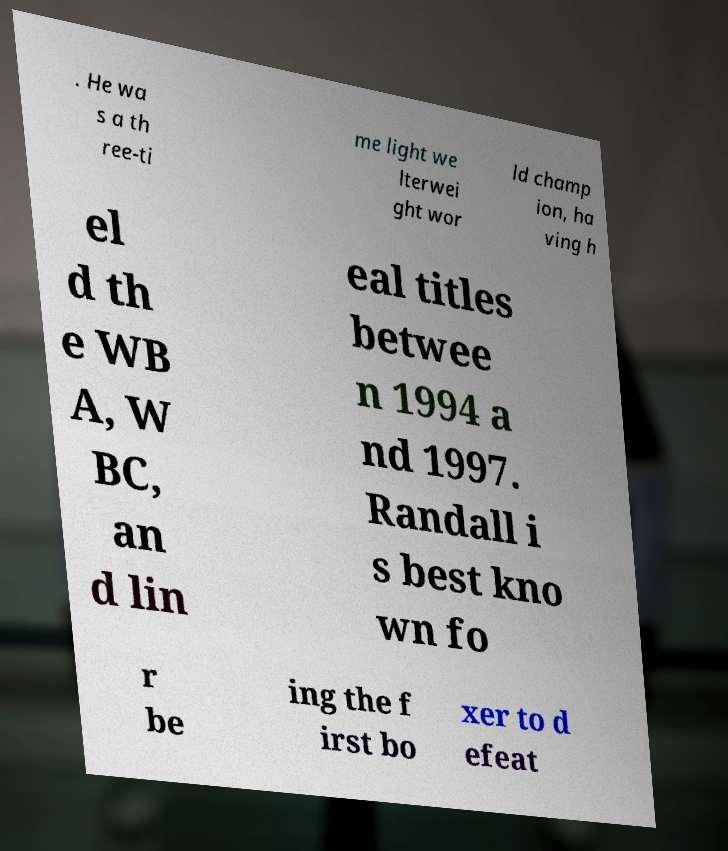What messages or text are displayed in this image? I need them in a readable, typed format. . He wa s a th ree-ti me light we lterwei ght wor ld champ ion, ha ving h el d th e WB A, W BC, an d lin eal titles betwee n 1994 a nd 1997. Randall i s best kno wn fo r be ing the f irst bo xer to d efeat 